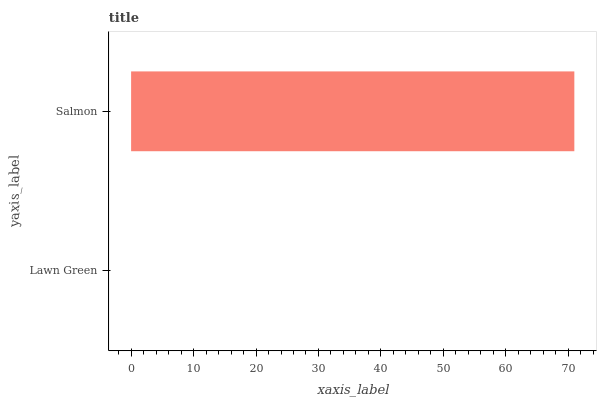Is Lawn Green the minimum?
Answer yes or no. Yes. Is Salmon the maximum?
Answer yes or no. Yes. Is Salmon the minimum?
Answer yes or no. No. Is Salmon greater than Lawn Green?
Answer yes or no. Yes. Is Lawn Green less than Salmon?
Answer yes or no. Yes. Is Lawn Green greater than Salmon?
Answer yes or no. No. Is Salmon less than Lawn Green?
Answer yes or no. No. Is Salmon the high median?
Answer yes or no. Yes. Is Lawn Green the low median?
Answer yes or no. Yes. Is Lawn Green the high median?
Answer yes or no. No. Is Salmon the low median?
Answer yes or no. No. 